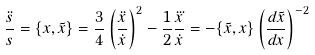<formula> <loc_0><loc_0><loc_500><loc_500>\frac { \ddot { s } } { s } = \{ x , \tilde { x } \} = \frac { 3 } { 4 } \left ( \frac { \ddot { x } } { \dot { x } } \right ) ^ { 2 } - \frac { 1 } { 2 } \frac { \dddot { x } } { \dot { x } } = - \{ \tilde { x } , x \} \left ( \frac { d \tilde { x } } { d x } \right ) ^ { - 2 }</formula> 